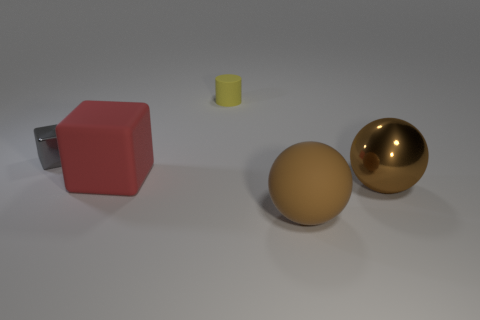What color is the big ball in front of the shiny object right of the gray cube behind the red matte thing?
Ensure brevity in your answer.  Brown. How many other objects are there of the same material as the yellow thing?
Ensure brevity in your answer.  2. There is a object that is behind the small shiny thing; is its shape the same as the brown matte object?
Ensure brevity in your answer.  No. What number of small things are gray metallic objects or red objects?
Ensure brevity in your answer.  1. Is the number of yellow rubber cylinders that are behind the yellow thing the same as the number of brown metal objects that are on the left side of the brown matte object?
Provide a short and direct response. Yes. What number of other objects are there of the same color as the matte cylinder?
Ensure brevity in your answer.  0. Is the color of the big rubber sphere the same as the metallic object that is on the left side of the metallic ball?
Keep it short and to the point. No. What number of red objects are either metallic cylinders or tiny shiny things?
Offer a terse response. 0. Are there the same number of yellow cylinders that are on the right side of the tiny yellow matte cylinder and yellow rubber blocks?
Your response must be concise. Yes. Is there any other thing that has the same size as the red rubber cube?
Make the answer very short. Yes. 